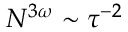<formula> <loc_0><loc_0><loc_500><loc_500>N ^ { 3 \omega } \sim \tau ^ { - 2 }</formula> 